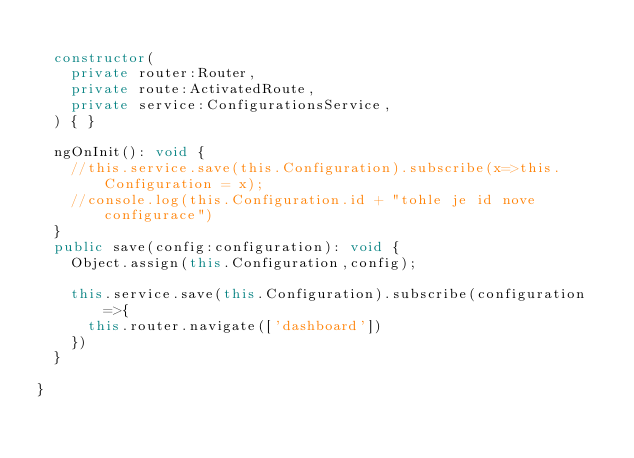<code> <loc_0><loc_0><loc_500><loc_500><_TypeScript_>
  constructor(
    private router:Router,
    private route:ActivatedRoute,
    private service:ConfigurationsService,
  ) { }

  ngOnInit(): void {
    //this.service.save(this.Configuration).subscribe(x=>this.Configuration = x);
    //console.log(this.Configuration.id + "tohle je id nove configurace")
  }
  public save(config:configuration): void {
    Object.assign(this.Configuration,config);

    this.service.save(this.Configuration).subscribe(configuration=>{
      this.router.navigate(['dashboard'])
    })
  }

}

</code> 